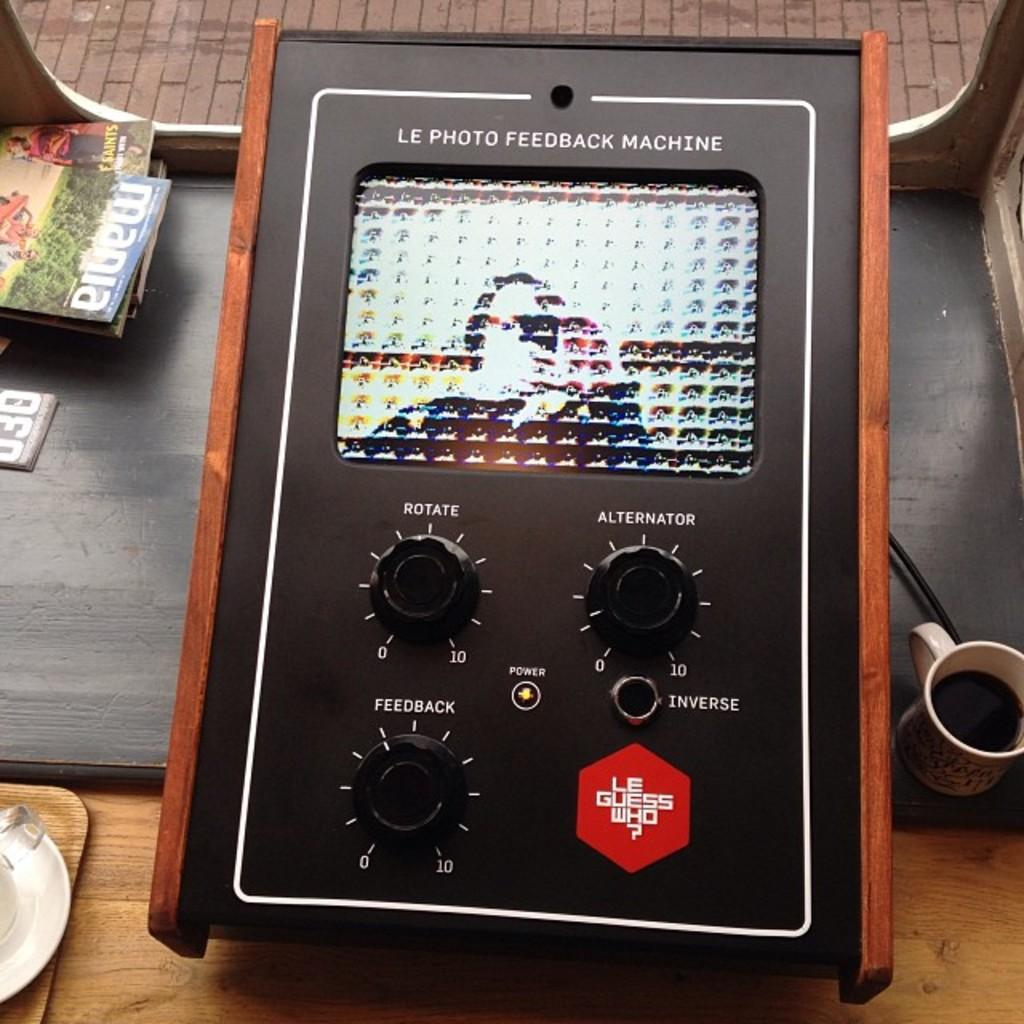<image>
Describe the image concisely. Featuring a Photo Feedback machine from Le Guess Who? Company. 